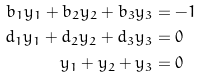Convert formula to latex. <formula><loc_0><loc_0><loc_500><loc_500>b _ { 1 } y _ { 1 } + b _ { 2 } y _ { 2 } + b _ { 3 } y _ { 3 } & = - 1 \\ d _ { 1 } y _ { 1 } + d _ { 2 } y _ { 2 } + d _ { 3 } y _ { 3 } & = 0 \\ y _ { 1 } + y _ { 2 } + y _ { 3 } & = 0</formula> 